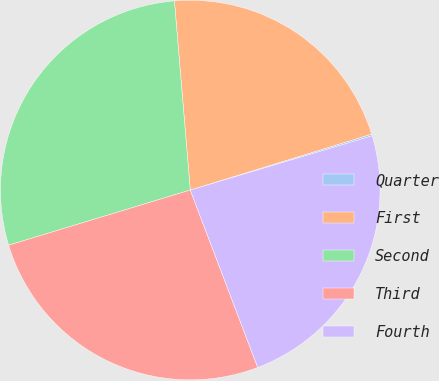Convert chart. <chart><loc_0><loc_0><loc_500><loc_500><pie_chart><fcel>Quarter<fcel>First<fcel>Second<fcel>Third<fcel>Fourth<nl><fcel>0.15%<fcel>21.57%<fcel>28.36%<fcel>26.09%<fcel>23.83%<nl></chart> 